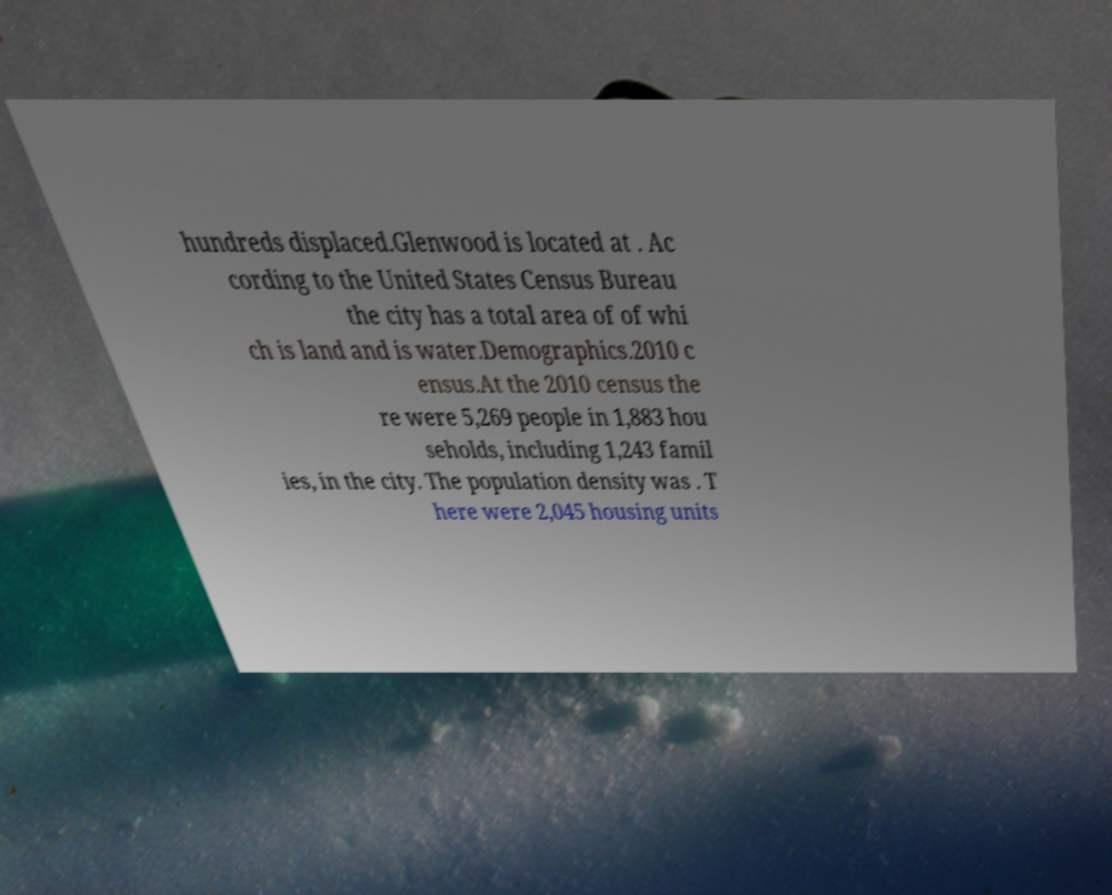Please read and relay the text visible in this image. What does it say? hundreds displaced.Glenwood is located at . Ac cording to the United States Census Bureau the city has a total area of of whi ch is land and is water.Demographics.2010 c ensus.At the 2010 census the re were 5,269 people in 1,883 hou seholds, including 1,243 famil ies, in the city. The population density was . T here were 2,045 housing units 